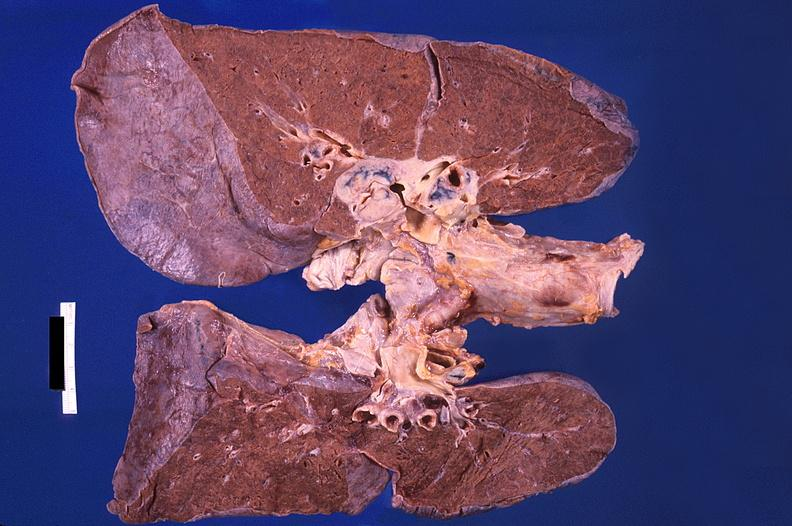how does this image show hilar lymph nodes, nodular sclerosing hodgkins disease and diffuse alveolar damage?
Answer the question using a single word or phrase. With hemorrhagic pneumonia 